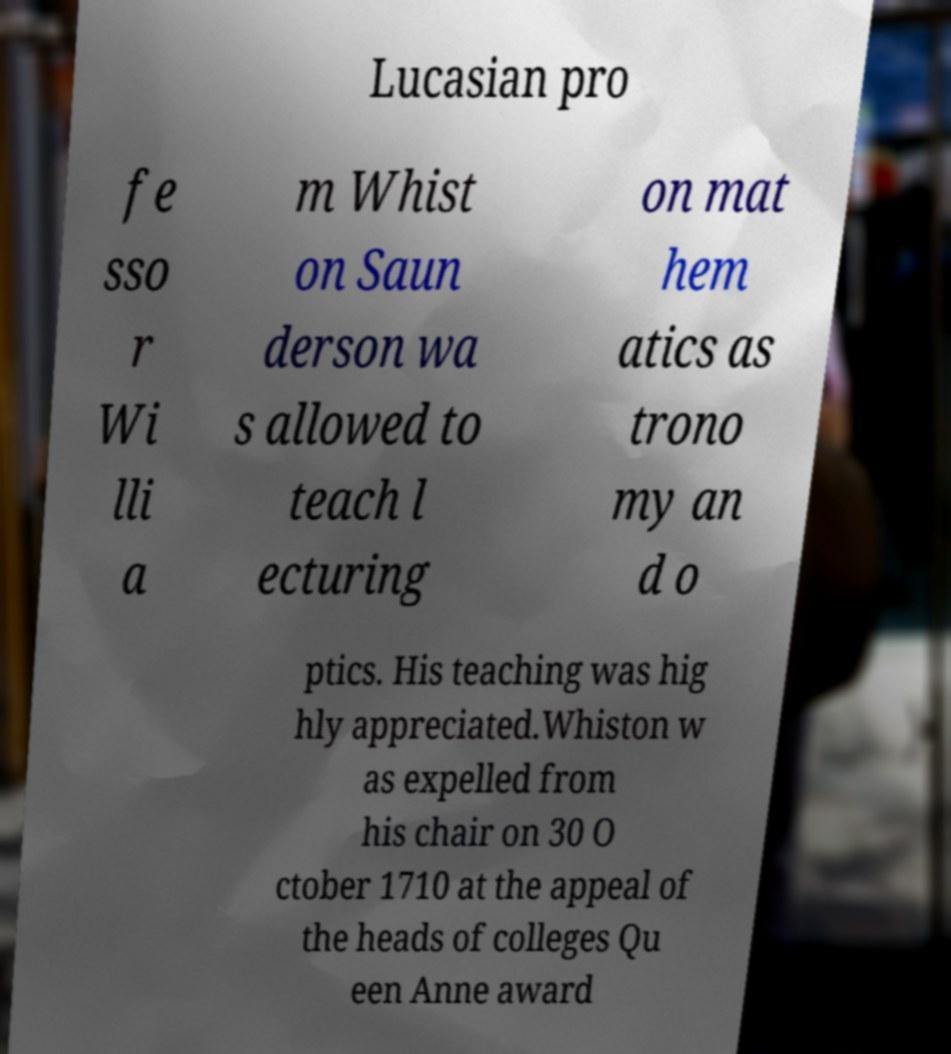I need the written content from this picture converted into text. Can you do that? Lucasian pro fe sso r Wi lli a m Whist on Saun derson wa s allowed to teach l ecturing on mat hem atics as trono my an d o ptics. His teaching was hig hly appreciated.Whiston w as expelled from his chair on 30 O ctober 1710 at the appeal of the heads of colleges Qu een Anne award 